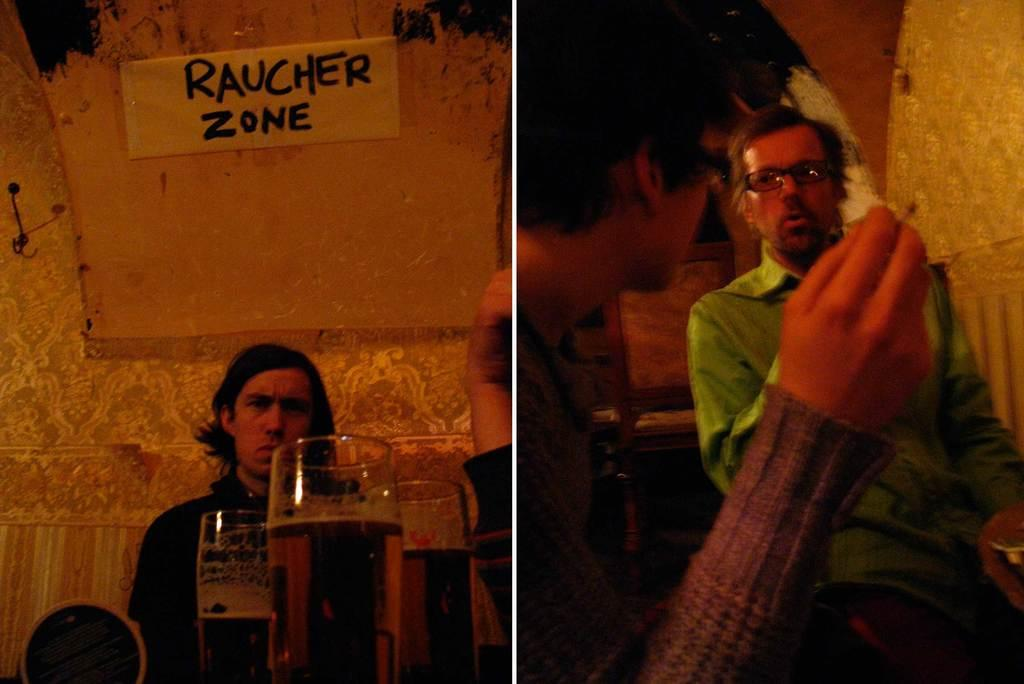<image>
Create a compact narrative representing the image presented. Two men and some glasses of beer with a Raucher Zone banner. 